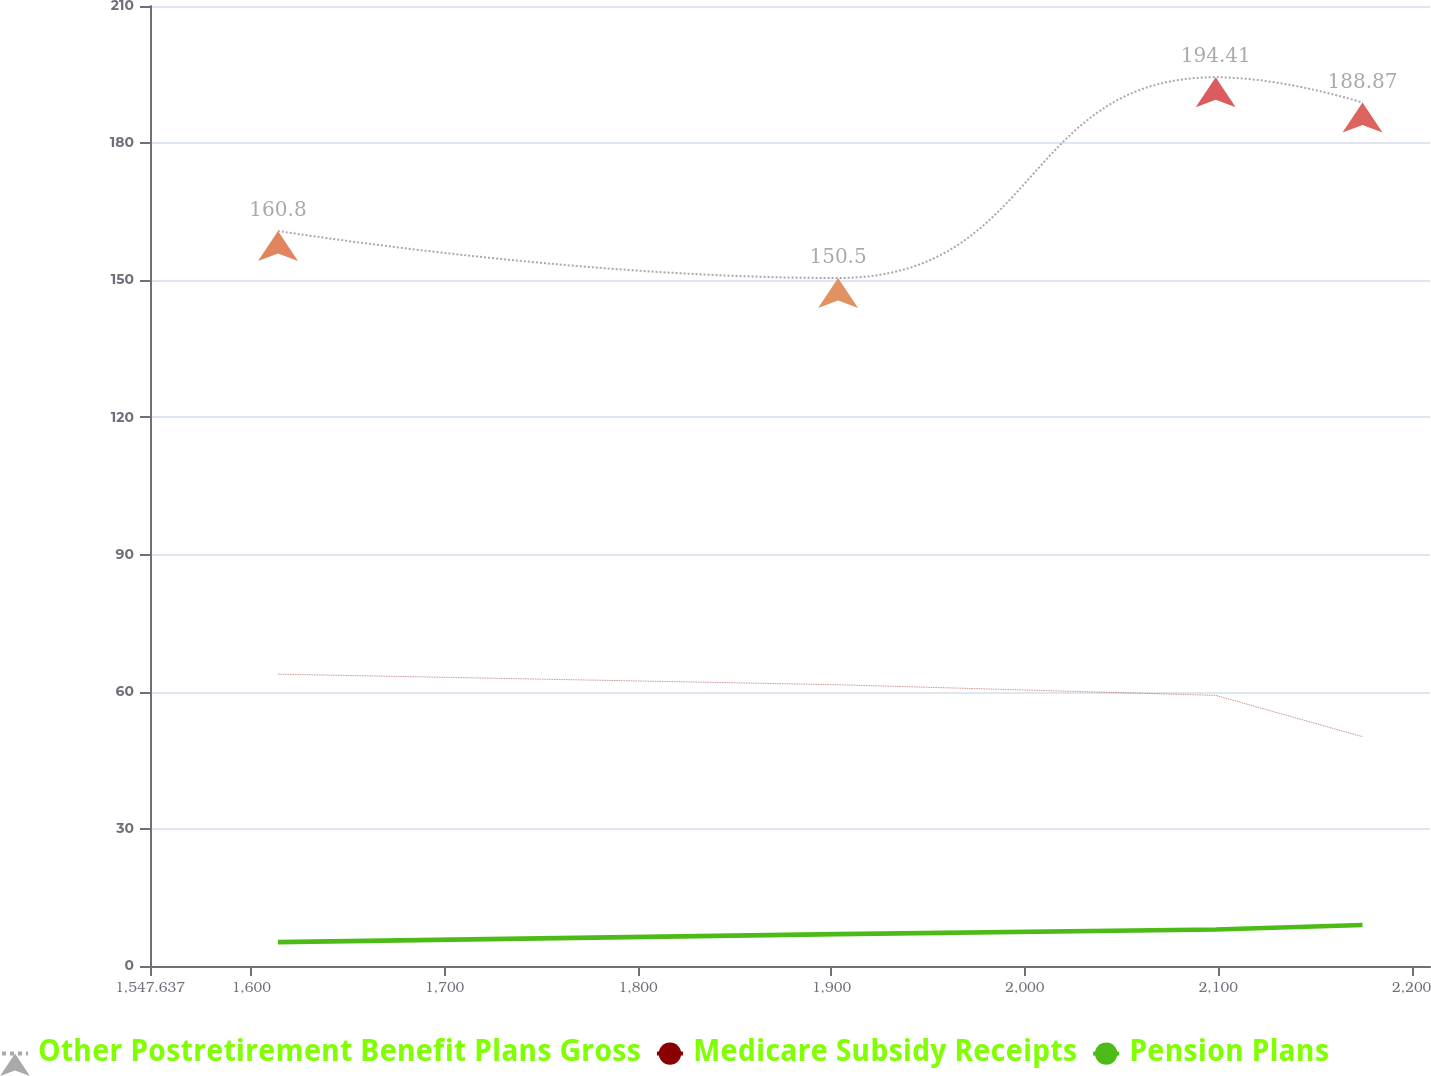Convert chart. <chart><loc_0><loc_0><loc_500><loc_500><line_chart><ecel><fcel>Other Postretirement Benefit Plans Gross<fcel>Medicare Subsidy Receipts<fcel>Pension Plans<nl><fcel>1613.82<fcel>160.8<fcel>63.84<fcel>5.23<nl><fcel>1903.41<fcel>150.5<fcel>61.52<fcel>6.98<nl><fcel>2098.66<fcel>194.41<fcel>59.2<fcel>8<nl><fcel>2174.57<fcel>188.87<fcel>50.16<fcel>8.98<nl><fcel>2275.65<fcel>205.9<fcel>73.36<fcel>7.41<nl></chart> 